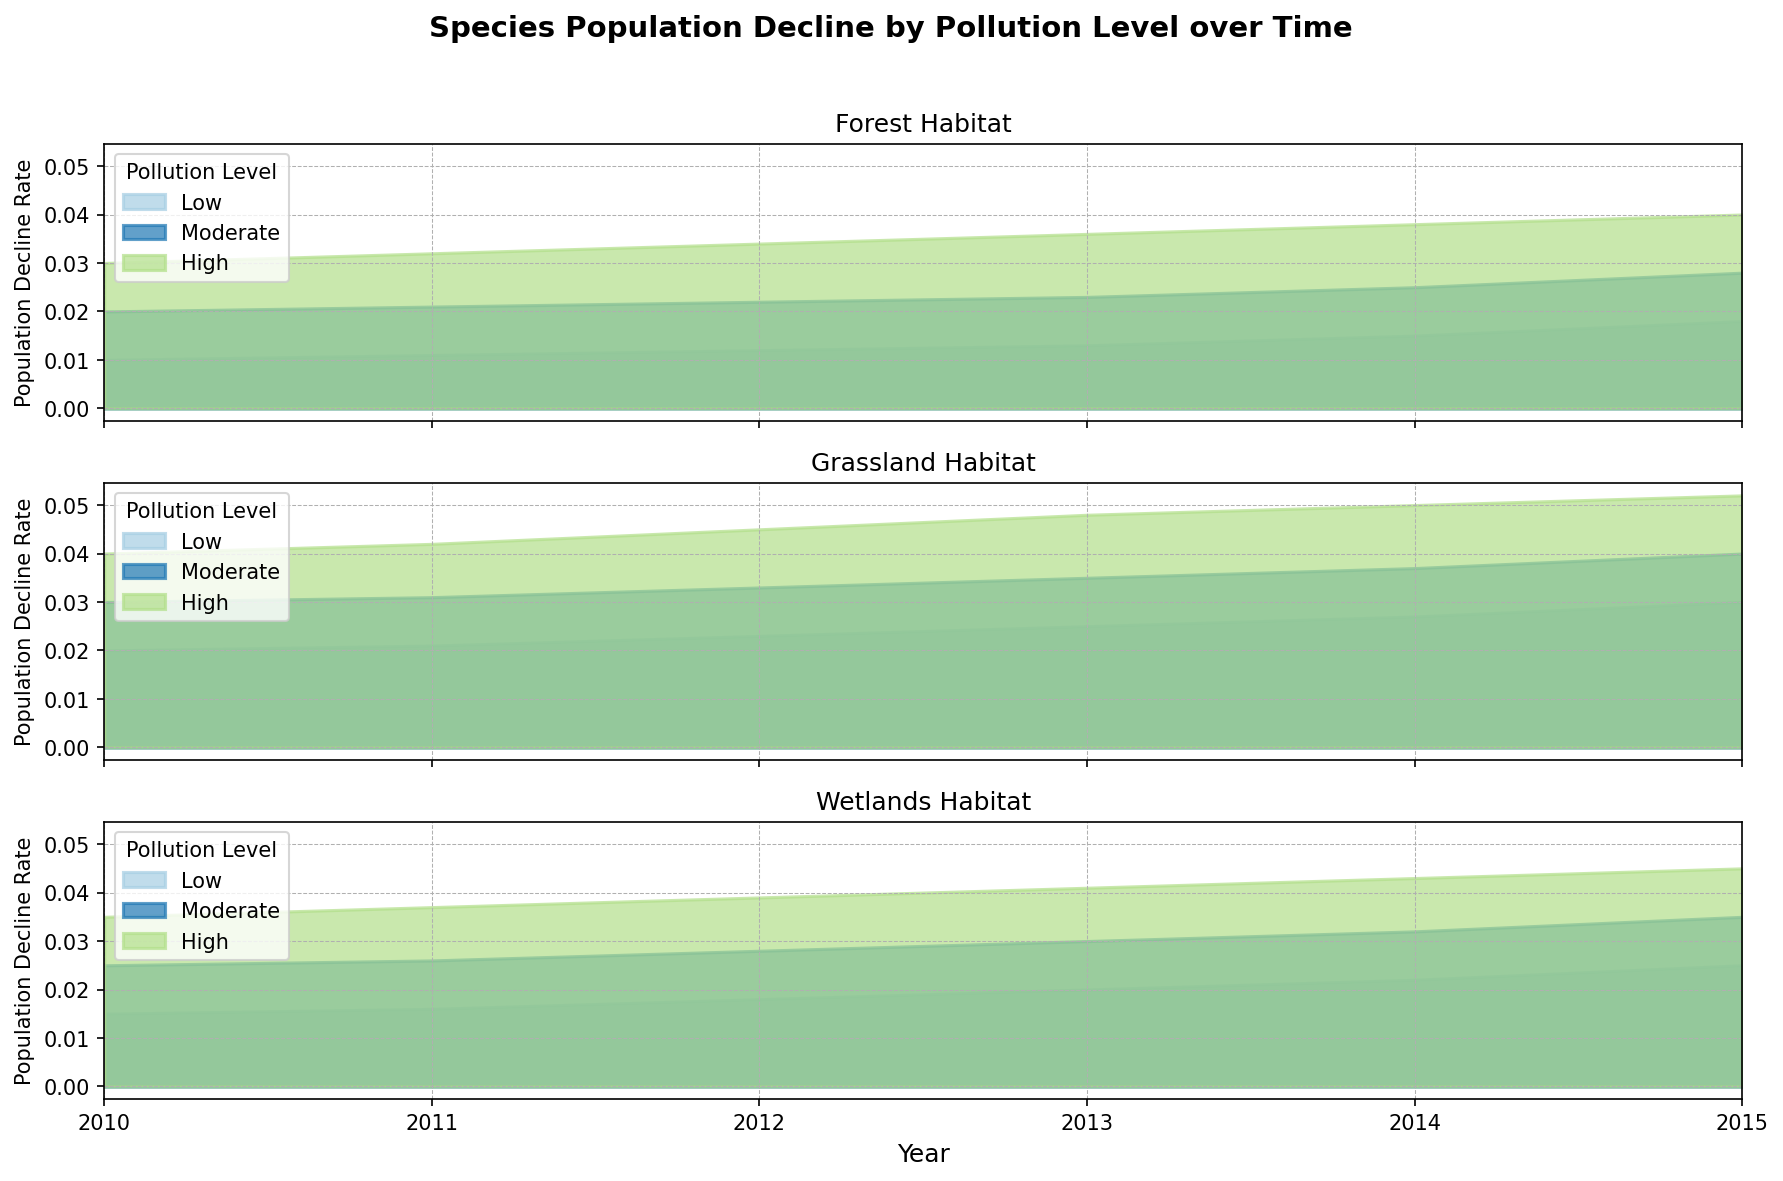What's the general trend over time for population decline rates in wetland habitats? Wetland habitats show a steady increase in population decline rates over the years 2010 to 2015 for all pollution levels. This can be observed as the areas for each pollution level expand upward each year.
Answer: Increasing Which habitat type shows the highest population decline rate in 2015 at high pollution levels? By comparing the highest points on the y-axis for each habitat type in 2015, the grassland habitat reaches the highest population decline rate at high pollution levels.
Answer: Grassland How does the population decline rate at low pollution levels in 2010 compare between forest and grassland habitats? For low pollution levels in 2010, comparing the heights of the lowest colored areas: forest declines by 0.01, while grassland declines by 0.02.
Answer: Grassland has a higher rate Do population decline rates for moderate pollution levels in wetland habitats ever surpass those of high pollution levels in forest habitats? From the figure, even the highest points of moderate pollution levels in wetlands never exceed the points of high pollution levels in forests. Wetlands' moderate level tops out at 0.035, while forests' high level starts at 0.03 and increases to 0.045 by 2015.
Answer: No In which years do grassland habitats show changes in the population decline rate for high pollution levels? Notably, grassland habitats show changes in the high pollution levels every year from 2010 to 2015. Each year sees a progressive increase in the height of the area representing high pollution.
Answer: Every year Which habitat type has the smallest population decline rate in 2013 at moderate pollution levels? Looking at the moderate pollution level areas in 2013, the forest habitat has the smallest population decline rate, indicated by the height of the moderate pollution level in the forest being lower than in grassland and wetlands.
Answer: Forest What are the rates of population decline across all habitats and pollution levels in 2011? Analyzing each habitat in 2011: Forest (Low: 0.011, Moderate: 0.021, High: 0.032), Grassland (Low: 0.021, Moderate: 0.031, High: 0.042), Wetlands (Low: 0.016, Moderate: 0.026, High: 0.037).
Answer: Rates vary by habitat and pollution level Which year shows the highest increase in population decline rate for low pollution levels in forest habitats? Observing the heights of the areas for low pollution levels in forest habitats year-by-year, the largest increase in height occurs between 2014 (0.015) and 2015 (0.018), indicating the highest increase.
Answer: 2014 to 2015 Is the population decline rate at moderate pollution levels always higher than at low pollution levels across all habitats? By visually inspecting each habitat panel, in all cases, the area representing moderate pollution levels is consistently above that of low pollution levels throughout the years.
Answer: Yes Compare the trend of population decline rates in wetlands and grasslands for low pollution levels from 2010 to 2015. For wetlands and grasslands, both show an upward trend: wetlands from 0.015 to 0.025 and grasslands from 0.02 to 0.03, observed by the height rise in the low pollution areas for both habitats.
Answer: Both increase 